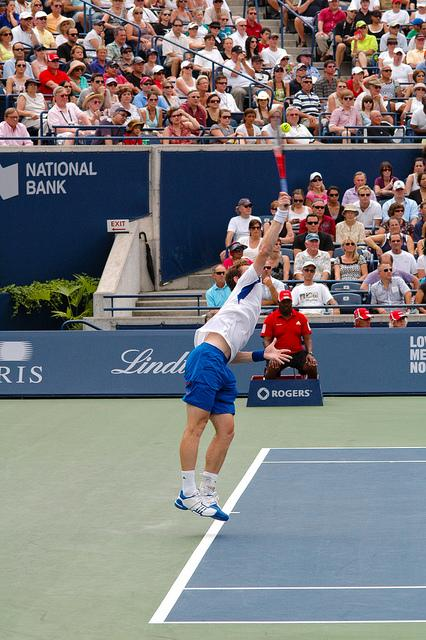Why is his arm up in the air? serving 